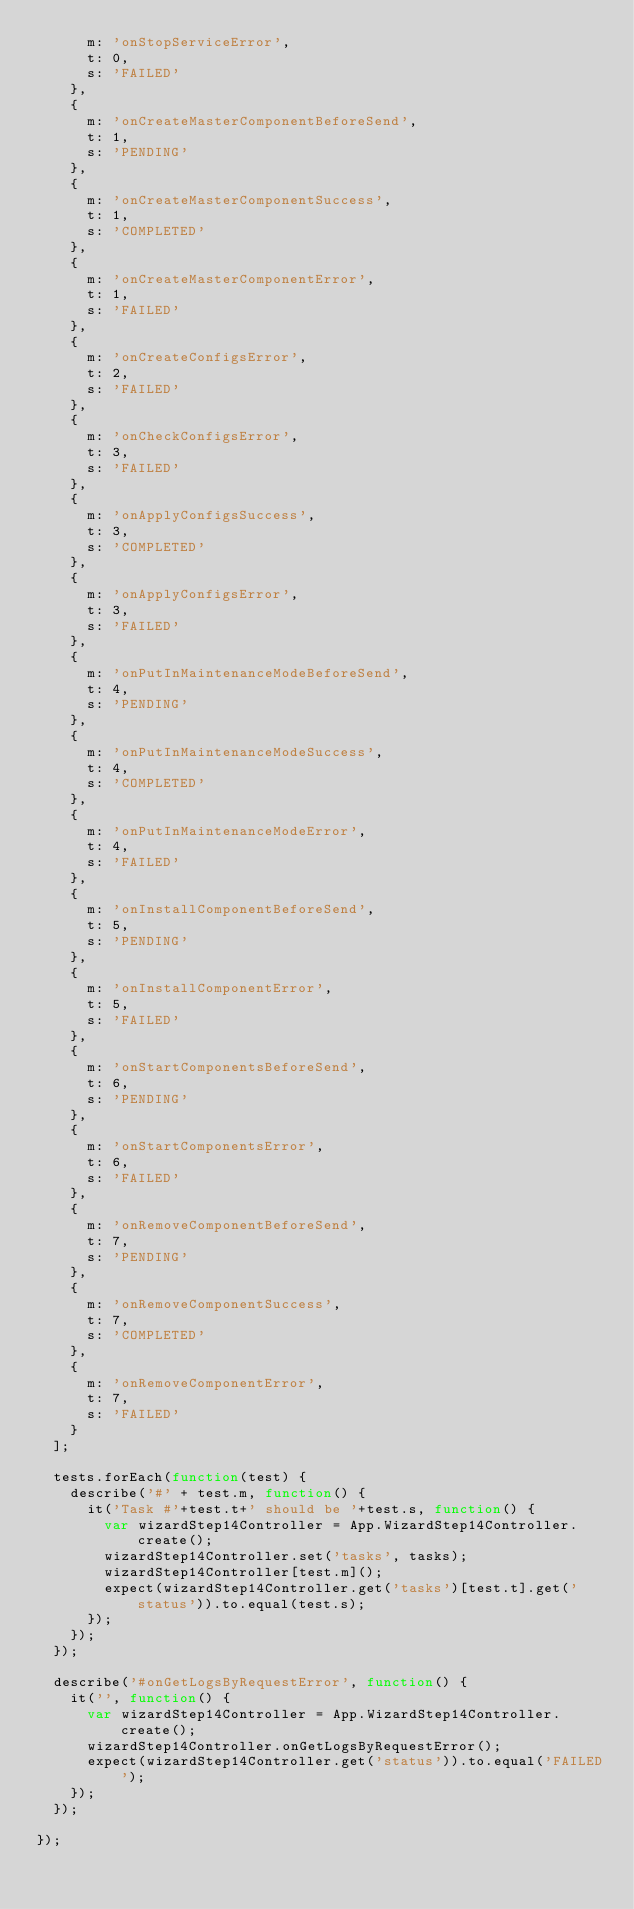<code> <loc_0><loc_0><loc_500><loc_500><_JavaScript_>      m: 'onStopServiceError',
      t: 0,
      s: 'FAILED'
    },
    {
      m: 'onCreateMasterComponentBeforeSend',
      t: 1,
      s: 'PENDING'
    },
    {
      m: 'onCreateMasterComponentSuccess',
      t: 1,
      s: 'COMPLETED'
    },
    {
      m: 'onCreateMasterComponentError',
      t: 1,
      s: 'FAILED'
    },
    {
      m: 'onCreateConfigsError',
      t: 2,
      s: 'FAILED'
    },
    {
      m: 'onCheckConfigsError',
      t: 3,
      s: 'FAILED'
    },
    {
      m: 'onApplyConfigsSuccess',
      t: 3,
      s: 'COMPLETED'
    },
    {
      m: 'onApplyConfigsError',
      t: 3,
      s: 'FAILED'
    },
    {
      m: 'onPutInMaintenanceModeBeforeSend',
      t: 4,
      s: 'PENDING'
    },
    {
      m: 'onPutInMaintenanceModeSuccess',
      t: 4,
      s: 'COMPLETED'
    },
    {
      m: 'onPutInMaintenanceModeError',
      t: 4,
      s: 'FAILED'
    },
    {
      m: 'onInstallComponentBeforeSend',
      t: 5,
      s: 'PENDING'
    },
    {
      m: 'onInstallComponentError',
      t: 5,
      s: 'FAILED'
    },
    {
      m: 'onStartComponentsBeforeSend',
      t: 6,
      s: 'PENDING'
    },
    {
      m: 'onStartComponentsError',
      t: 6,
      s: 'FAILED'
    },
    {
      m: 'onRemoveComponentBeforeSend',
      t: 7,
      s: 'PENDING'
    },
    {
      m: 'onRemoveComponentSuccess',
      t: 7,
      s: 'COMPLETED'
    },
    {
      m: 'onRemoveComponentError',
      t: 7,
      s: 'FAILED'
    }
  ];

  tests.forEach(function(test) {
    describe('#' + test.m, function() {
      it('Task #'+test.t+' should be '+test.s, function() {
        var wizardStep14Controller = App.WizardStep14Controller.create();
        wizardStep14Controller.set('tasks', tasks);
        wizardStep14Controller[test.m]();
        expect(wizardStep14Controller.get('tasks')[test.t].get('status')).to.equal(test.s);
      });
    });
  });

  describe('#onGetLogsByRequestError', function() {
    it('', function() {
      var wizardStep14Controller = App.WizardStep14Controller.create();
      wizardStep14Controller.onGetLogsByRequestError();
      expect(wizardStep14Controller.get('status')).to.equal('FAILED');
    });
  });

});
</code> 